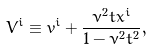Convert formula to latex. <formula><loc_0><loc_0><loc_500><loc_500>V ^ { i } \equiv v ^ { i } + \frac { \nu ^ { 2 } t x ^ { i } } { 1 - \nu ^ { 2 } t ^ { 2 } } ,</formula> 